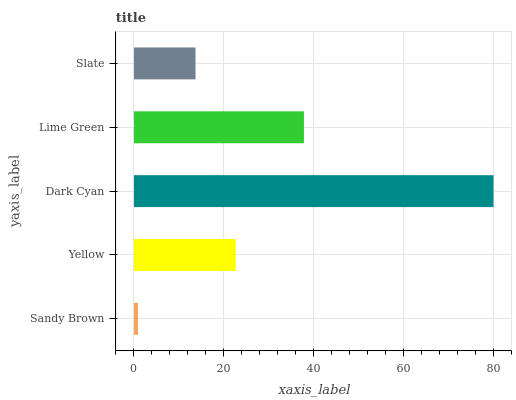Is Sandy Brown the minimum?
Answer yes or no. Yes. Is Dark Cyan the maximum?
Answer yes or no. Yes. Is Yellow the minimum?
Answer yes or no. No. Is Yellow the maximum?
Answer yes or no. No. Is Yellow greater than Sandy Brown?
Answer yes or no. Yes. Is Sandy Brown less than Yellow?
Answer yes or no. Yes. Is Sandy Brown greater than Yellow?
Answer yes or no. No. Is Yellow less than Sandy Brown?
Answer yes or no. No. Is Yellow the high median?
Answer yes or no. Yes. Is Yellow the low median?
Answer yes or no. Yes. Is Lime Green the high median?
Answer yes or no. No. Is Slate the low median?
Answer yes or no. No. 